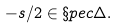<formula> <loc_0><loc_0><loc_500><loc_500>- s / 2 \in \S p e c \Delta .</formula> 